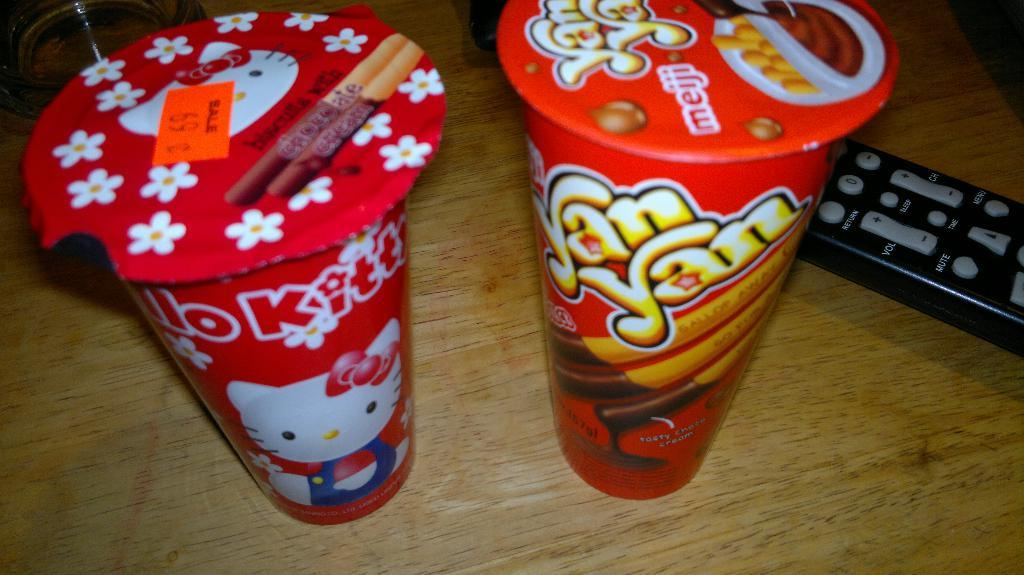<image>
Provide a brief description of the given image. Two cups of wafer cookie sticks, one called "Yan Yan" stand next to each other beside a remote control. 